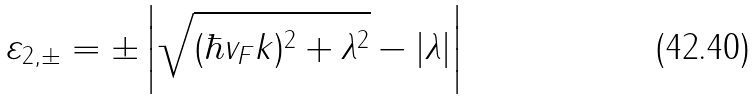<formula> <loc_0><loc_0><loc_500><loc_500>\varepsilon _ { 2 , \pm } = \pm \left | \sqrt { ( \hbar { v } _ { F } k ) ^ { 2 } + \lambda ^ { 2 } } - | \lambda | \right |</formula> 